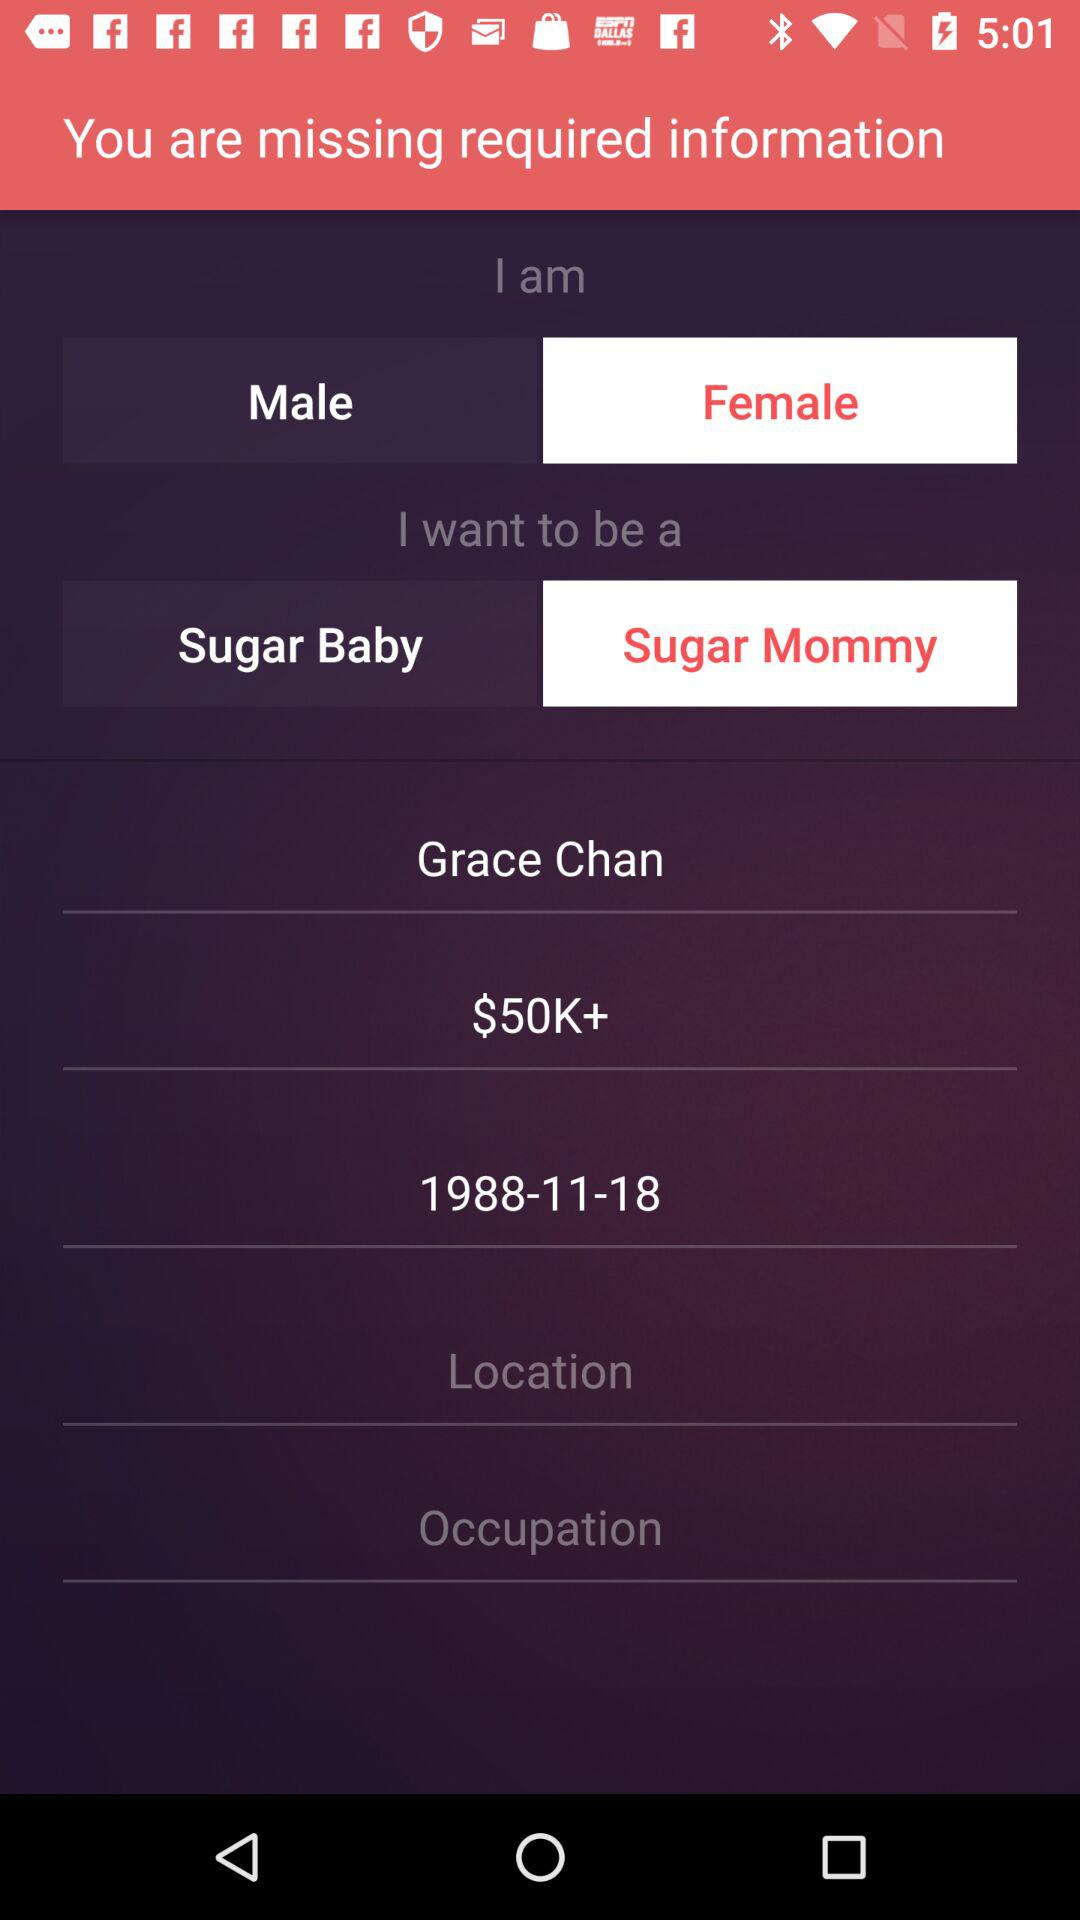Where is Grace Chan located?
When the provided information is insufficient, respond with <no answer>. <no answer> 